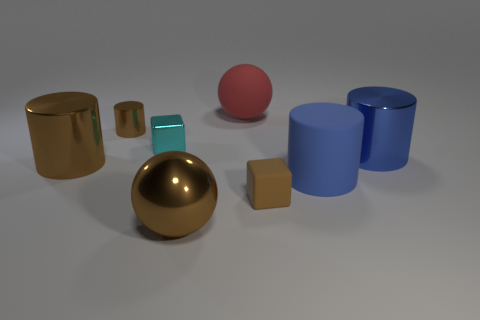What number of shiny objects have the same color as the tiny rubber object?
Ensure brevity in your answer.  3. There is a block that is the same color as the metal sphere; what is its material?
Provide a succinct answer. Rubber. What number of matte objects are big blue things or big brown balls?
Offer a terse response. 1. Is the shape of the tiny brown object right of the tiny cyan shiny cube the same as the small cyan metal object on the left side of the brown sphere?
Your answer should be compact. Yes. There is a large brown metal cylinder; how many tiny brown metal cylinders are left of it?
Your response must be concise. 0. Is there a tiny brown block made of the same material as the large red ball?
Your answer should be very brief. Yes. What material is the brown ball that is the same size as the blue matte thing?
Your answer should be compact. Metal. Are the large red thing and the small brown block made of the same material?
Your answer should be compact. Yes. How many objects are either tiny brown blocks or tiny green matte things?
Provide a succinct answer. 1. What is the shape of the shiny object that is on the right side of the blue rubber cylinder?
Provide a succinct answer. Cylinder. 